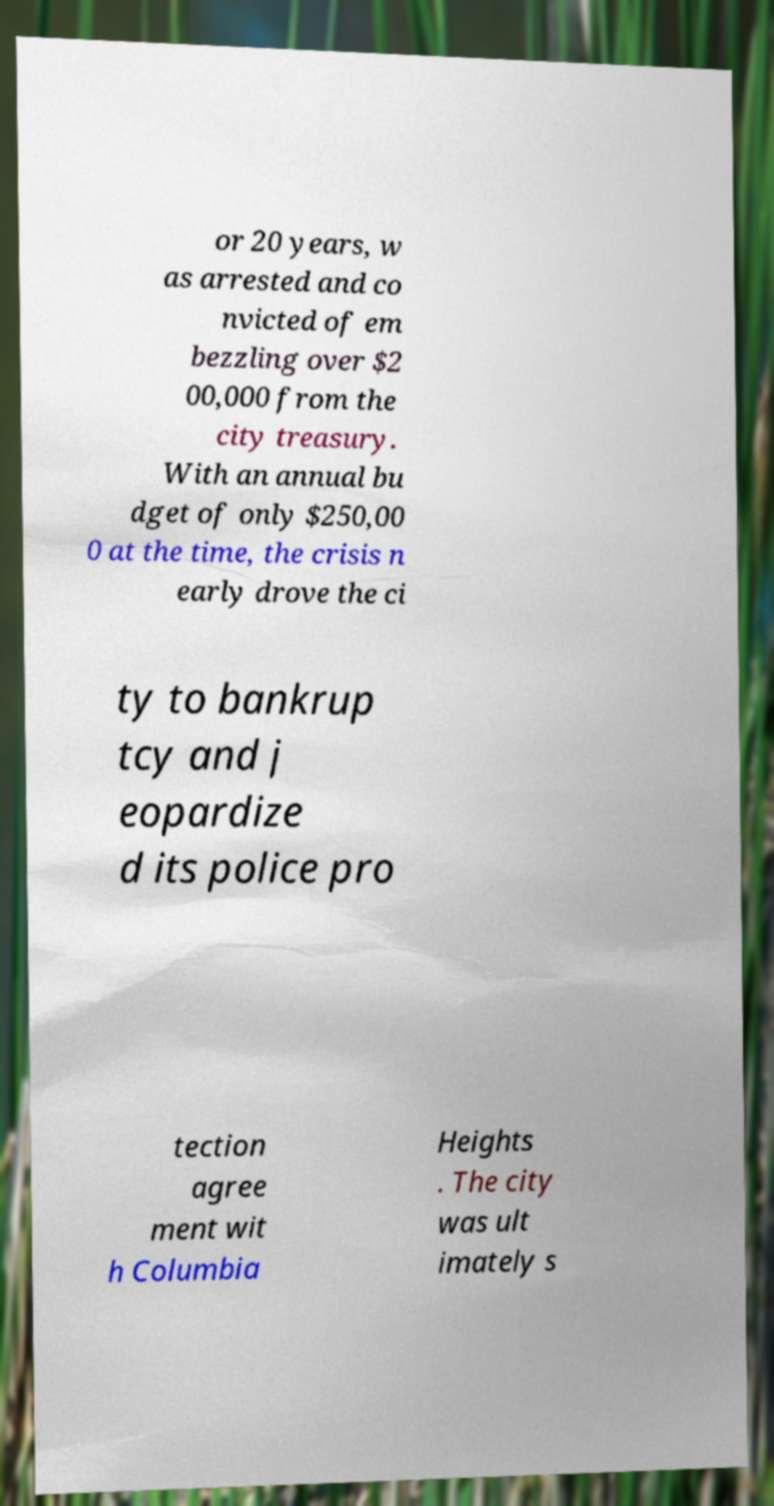Please identify and transcribe the text found in this image. or 20 years, w as arrested and co nvicted of em bezzling over $2 00,000 from the city treasury. With an annual bu dget of only $250,00 0 at the time, the crisis n early drove the ci ty to bankrup tcy and j eopardize d its police pro tection agree ment wit h Columbia Heights . The city was ult imately s 